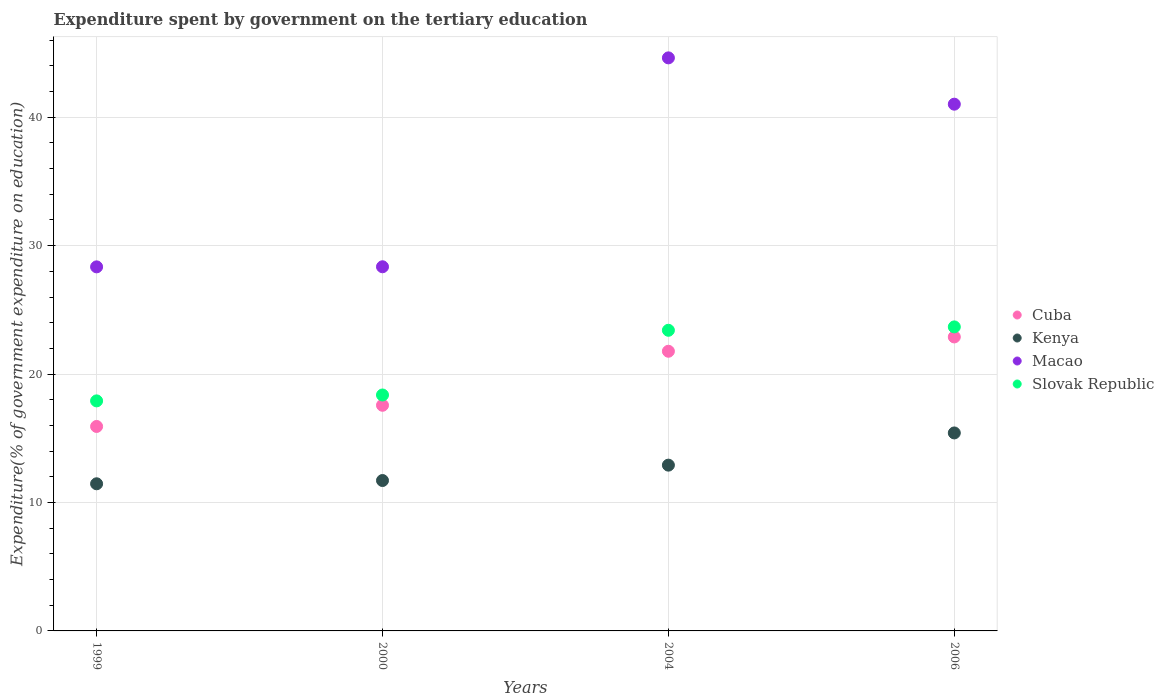How many different coloured dotlines are there?
Ensure brevity in your answer.  4. Is the number of dotlines equal to the number of legend labels?
Offer a terse response. Yes. What is the expenditure spent by government on the tertiary education in Slovak Republic in 1999?
Offer a very short reply. 17.91. Across all years, what is the maximum expenditure spent by government on the tertiary education in Cuba?
Your answer should be compact. 22.89. Across all years, what is the minimum expenditure spent by government on the tertiary education in Cuba?
Keep it short and to the point. 15.92. In which year was the expenditure spent by government on the tertiary education in Kenya minimum?
Make the answer very short. 1999. What is the total expenditure spent by government on the tertiary education in Cuba in the graph?
Provide a succinct answer. 78.17. What is the difference between the expenditure spent by government on the tertiary education in Slovak Republic in 2000 and that in 2006?
Your answer should be compact. -5.3. What is the difference between the expenditure spent by government on the tertiary education in Kenya in 2004 and the expenditure spent by government on the tertiary education in Cuba in 1999?
Offer a very short reply. -3.01. What is the average expenditure spent by government on the tertiary education in Cuba per year?
Your response must be concise. 19.54. In the year 2004, what is the difference between the expenditure spent by government on the tertiary education in Macao and expenditure spent by government on the tertiary education in Slovak Republic?
Provide a succinct answer. 21.21. In how many years, is the expenditure spent by government on the tertiary education in Cuba greater than 16 %?
Your answer should be compact. 3. What is the ratio of the expenditure spent by government on the tertiary education in Slovak Republic in 1999 to that in 2004?
Provide a short and direct response. 0.77. What is the difference between the highest and the second highest expenditure spent by government on the tertiary education in Kenya?
Provide a succinct answer. 2.51. What is the difference between the highest and the lowest expenditure spent by government on the tertiary education in Macao?
Ensure brevity in your answer.  16.27. Is it the case that in every year, the sum of the expenditure spent by government on the tertiary education in Slovak Republic and expenditure spent by government on the tertiary education in Kenya  is greater than the sum of expenditure spent by government on the tertiary education in Macao and expenditure spent by government on the tertiary education in Cuba?
Make the answer very short. No. Is it the case that in every year, the sum of the expenditure spent by government on the tertiary education in Cuba and expenditure spent by government on the tertiary education in Macao  is greater than the expenditure spent by government on the tertiary education in Slovak Republic?
Provide a short and direct response. Yes. Does the expenditure spent by government on the tertiary education in Cuba monotonically increase over the years?
Make the answer very short. Yes. Is the expenditure spent by government on the tertiary education in Cuba strictly greater than the expenditure spent by government on the tertiary education in Kenya over the years?
Offer a very short reply. Yes. Is the expenditure spent by government on the tertiary education in Kenya strictly less than the expenditure spent by government on the tertiary education in Macao over the years?
Your answer should be compact. Yes. How many years are there in the graph?
Give a very brief answer. 4. Where does the legend appear in the graph?
Offer a very short reply. Center right. How many legend labels are there?
Provide a short and direct response. 4. What is the title of the graph?
Keep it short and to the point. Expenditure spent by government on the tertiary education. Does "Bulgaria" appear as one of the legend labels in the graph?
Offer a terse response. No. What is the label or title of the X-axis?
Keep it short and to the point. Years. What is the label or title of the Y-axis?
Keep it short and to the point. Expenditure(% of government expenditure on education). What is the Expenditure(% of government expenditure on education) of Cuba in 1999?
Your answer should be very brief. 15.92. What is the Expenditure(% of government expenditure on education) in Kenya in 1999?
Make the answer very short. 11.46. What is the Expenditure(% of government expenditure on education) in Macao in 1999?
Ensure brevity in your answer.  28.35. What is the Expenditure(% of government expenditure on education) of Slovak Republic in 1999?
Offer a terse response. 17.91. What is the Expenditure(% of government expenditure on education) of Cuba in 2000?
Your answer should be compact. 17.57. What is the Expenditure(% of government expenditure on education) of Kenya in 2000?
Keep it short and to the point. 11.71. What is the Expenditure(% of government expenditure on education) in Macao in 2000?
Your answer should be compact. 28.36. What is the Expenditure(% of government expenditure on education) in Slovak Republic in 2000?
Keep it short and to the point. 18.37. What is the Expenditure(% of government expenditure on education) of Cuba in 2004?
Your response must be concise. 21.78. What is the Expenditure(% of government expenditure on education) of Kenya in 2004?
Your response must be concise. 12.91. What is the Expenditure(% of government expenditure on education) in Macao in 2004?
Provide a short and direct response. 44.63. What is the Expenditure(% of government expenditure on education) of Slovak Republic in 2004?
Offer a very short reply. 23.41. What is the Expenditure(% of government expenditure on education) of Cuba in 2006?
Offer a very short reply. 22.89. What is the Expenditure(% of government expenditure on education) in Kenya in 2006?
Keep it short and to the point. 15.42. What is the Expenditure(% of government expenditure on education) of Macao in 2006?
Make the answer very short. 41.02. What is the Expenditure(% of government expenditure on education) of Slovak Republic in 2006?
Ensure brevity in your answer.  23.68. Across all years, what is the maximum Expenditure(% of government expenditure on education) of Cuba?
Offer a very short reply. 22.89. Across all years, what is the maximum Expenditure(% of government expenditure on education) in Kenya?
Your response must be concise. 15.42. Across all years, what is the maximum Expenditure(% of government expenditure on education) of Macao?
Your response must be concise. 44.63. Across all years, what is the maximum Expenditure(% of government expenditure on education) in Slovak Republic?
Ensure brevity in your answer.  23.68. Across all years, what is the minimum Expenditure(% of government expenditure on education) of Cuba?
Provide a short and direct response. 15.92. Across all years, what is the minimum Expenditure(% of government expenditure on education) in Kenya?
Provide a succinct answer. 11.46. Across all years, what is the minimum Expenditure(% of government expenditure on education) in Macao?
Offer a very short reply. 28.35. Across all years, what is the minimum Expenditure(% of government expenditure on education) in Slovak Republic?
Your answer should be very brief. 17.91. What is the total Expenditure(% of government expenditure on education) in Cuba in the graph?
Provide a succinct answer. 78.17. What is the total Expenditure(% of government expenditure on education) of Kenya in the graph?
Your answer should be compact. 51.5. What is the total Expenditure(% of government expenditure on education) of Macao in the graph?
Keep it short and to the point. 142.35. What is the total Expenditure(% of government expenditure on education) of Slovak Republic in the graph?
Give a very brief answer. 83.37. What is the difference between the Expenditure(% of government expenditure on education) of Cuba in 1999 and that in 2000?
Keep it short and to the point. -1.65. What is the difference between the Expenditure(% of government expenditure on education) of Kenya in 1999 and that in 2000?
Offer a terse response. -0.25. What is the difference between the Expenditure(% of government expenditure on education) of Macao in 1999 and that in 2000?
Give a very brief answer. -0.01. What is the difference between the Expenditure(% of government expenditure on education) of Slovak Republic in 1999 and that in 2000?
Your response must be concise. -0.46. What is the difference between the Expenditure(% of government expenditure on education) of Cuba in 1999 and that in 2004?
Provide a short and direct response. -5.86. What is the difference between the Expenditure(% of government expenditure on education) of Kenya in 1999 and that in 2004?
Make the answer very short. -1.45. What is the difference between the Expenditure(% of government expenditure on education) in Macao in 1999 and that in 2004?
Your answer should be very brief. -16.27. What is the difference between the Expenditure(% of government expenditure on education) in Slovak Republic in 1999 and that in 2004?
Ensure brevity in your answer.  -5.5. What is the difference between the Expenditure(% of government expenditure on education) of Cuba in 1999 and that in 2006?
Provide a succinct answer. -6.97. What is the difference between the Expenditure(% of government expenditure on education) of Kenya in 1999 and that in 2006?
Ensure brevity in your answer.  -3.96. What is the difference between the Expenditure(% of government expenditure on education) in Macao in 1999 and that in 2006?
Provide a short and direct response. -12.67. What is the difference between the Expenditure(% of government expenditure on education) of Slovak Republic in 1999 and that in 2006?
Offer a very short reply. -5.76. What is the difference between the Expenditure(% of government expenditure on education) in Cuba in 2000 and that in 2004?
Provide a short and direct response. -4.21. What is the difference between the Expenditure(% of government expenditure on education) in Kenya in 2000 and that in 2004?
Offer a terse response. -1.2. What is the difference between the Expenditure(% of government expenditure on education) in Macao in 2000 and that in 2004?
Keep it short and to the point. -16.27. What is the difference between the Expenditure(% of government expenditure on education) in Slovak Republic in 2000 and that in 2004?
Make the answer very short. -5.04. What is the difference between the Expenditure(% of government expenditure on education) of Cuba in 2000 and that in 2006?
Make the answer very short. -5.32. What is the difference between the Expenditure(% of government expenditure on education) of Kenya in 2000 and that in 2006?
Ensure brevity in your answer.  -3.71. What is the difference between the Expenditure(% of government expenditure on education) of Macao in 2000 and that in 2006?
Offer a very short reply. -12.66. What is the difference between the Expenditure(% of government expenditure on education) of Slovak Republic in 2000 and that in 2006?
Give a very brief answer. -5.3. What is the difference between the Expenditure(% of government expenditure on education) of Cuba in 2004 and that in 2006?
Make the answer very short. -1.11. What is the difference between the Expenditure(% of government expenditure on education) of Kenya in 2004 and that in 2006?
Offer a very short reply. -2.51. What is the difference between the Expenditure(% of government expenditure on education) of Macao in 2004 and that in 2006?
Give a very brief answer. 3.61. What is the difference between the Expenditure(% of government expenditure on education) of Slovak Republic in 2004 and that in 2006?
Your answer should be compact. -0.26. What is the difference between the Expenditure(% of government expenditure on education) in Cuba in 1999 and the Expenditure(% of government expenditure on education) in Kenya in 2000?
Your answer should be very brief. 4.21. What is the difference between the Expenditure(% of government expenditure on education) of Cuba in 1999 and the Expenditure(% of government expenditure on education) of Macao in 2000?
Ensure brevity in your answer.  -12.44. What is the difference between the Expenditure(% of government expenditure on education) of Cuba in 1999 and the Expenditure(% of government expenditure on education) of Slovak Republic in 2000?
Your answer should be very brief. -2.45. What is the difference between the Expenditure(% of government expenditure on education) in Kenya in 1999 and the Expenditure(% of government expenditure on education) in Macao in 2000?
Keep it short and to the point. -16.9. What is the difference between the Expenditure(% of government expenditure on education) of Kenya in 1999 and the Expenditure(% of government expenditure on education) of Slovak Republic in 2000?
Offer a very short reply. -6.91. What is the difference between the Expenditure(% of government expenditure on education) of Macao in 1999 and the Expenditure(% of government expenditure on education) of Slovak Republic in 2000?
Your answer should be compact. 9.98. What is the difference between the Expenditure(% of government expenditure on education) in Cuba in 1999 and the Expenditure(% of government expenditure on education) in Kenya in 2004?
Provide a short and direct response. 3.01. What is the difference between the Expenditure(% of government expenditure on education) in Cuba in 1999 and the Expenditure(% of government expenditure on education) in Macao in 2004?
Provide a short and direct response. -28.7. What is the difference between the Expenditure(% of government expenditure on education) of Cuba in 1999 and the Expenditure(% of government expenditure on education) of Slovak Republic in 2004?
Offer a very short reply. -7.49. What is the difference between the Expenditure(% of government expenditure on education) of Kenya in 1999 and the Expenditure(% of government expenditure on education) of Macao in 2004?
Ensure brevity in your answer.  -33.17. What is the difference between the Expenditure(% of government expenditure on education) in Kenya in 1999 and the Expenditure(% of government expenditure on education) in Slovak Republic in 2004?
Ensure brevity in your answer.  -11.95. What is the difference between the Expenditure(% of government expenditure on education) of Macao in 1999 and the Expenditure(% of government expenditure on education) of Slovak Republic in 2004?
Provide a short and direct response. 4.94. What is the difference between the Expenditure(% of government expenditure on education) in Cuba in 1999 and the Expenditure(% of government expenditure on education) in Kenya in 2006?
Provide a succinct answer. 0.51. What is the difference between the Expenditure(% of government expenditure on education) in Cuba in 1999 and the Expenditure(% of government expenditure on education) in Macao in 2006?
Offer a terse response. -25.1. What is the difference between the Expenditure(% of government expenditure on education) of Cuba in 1999 and the Expenditure(% of government expenditure on education) of Slovak Republic in 2006?
Your response must be concise. -7.75. What is the difference between the Expenditure(% of government expenditure on education) in Kenya in 1999 and the Expenditure(% of government expenditure on education) in Macao in 2006?
Ensure brevity in your answer.  -29.56. What is the difference between the Expenditure(% of government expenditure on education) of Kenya in 1999 and the Expenditure(% of government expenditure on education) of Slovak Republic in 2006?
Ensure brevity in your answer.  -12.22. What is the difference between the Expenditure(% of government expenditure on education) of Macao in 1999 and the Expenditure(% of government expenditure on education) of Slovak Republic in 2006?
Your answer should be very brief. 4.67. What is the difference between the Expenditure(% of government expenditure on education) of Cuba in 2000 and the Expenditure(% of government expenditure on education) of Kenya in 2004?
Make the answer very short. 4.66. What is the difference between the Expenditure(% of government expenditure on education) in Cuba in 2000 and the Expenditure(% of government expenditure on education) in Macao in 2004?
Your response must be concise. -27.05. What is the difference between the Expenditure(% of government expenditure on education) of Cuba in 2000 and the Expenditure(% of government expenditure on education) of Slovak Republic in 2004?
Make the answer very short. -5.84. What is the difference between the Expenditure(% of government expenditure on education) of Kenya in 2000 and the Expenditure(% of government expenditure on education) of Macao in 2004?
Make the answer very short. -32.91. What is the difference between the Expenditure(% of government expenditure on education) in Kenya in 2000 and the Expenditure(% of government expenditure on education) in Slovak Republic in 2004?
Your answer should be very brief. -11.7. What is the difference between the Expenditure(% of government expenditure on education) of Macao in 2000 and the Expenditure(% of government expenditure on education) of Slovak Republic in 2004?
Your response must be concise. 4.95. What is the difference between the Expenditure(% of government expenditure on education) of Cuba in 2000 and the Expenditure(% of government expenditure on education) of Kenya in 2006?
Your answer should be compact. 2.15. What is the difference between the Expenditure(% of government expenditure on education) in Cuba in 2000 and the Expenditure(% of government expenditure on education) in Macao in 2006?
Provide a short and direct response. -23.45. What is the difference between the Expenditure(% of government expenditure on education) of Cuba in 2000 and the Expenditure(% of government expenditure on education) of Slovak Republic in 2006?
Your answer should be very brief. -6.1. What is the difference between the Expenditure(% of government expenditure on education) in Kenya in 2000 and the Expenditure(% of government expenditure on education) in Macao in 2006?
Provide a short and direct response. -29.31. What is the difference between the Expenditure(% of government expenditure on education) of Kenya in 2000 and the Expenditure(% of government expenditure on education) of Slovak Republic in 2006?
Provide a short and direct response. -11.96. What is the difference between the Expenditure(% of government expenditure on education) in Macao in 2000 and the Expenditure(% of government expenditure on education) in Slovak Republic in 2006?
Your answer should be compact. 4.68. What is the difference between the Expenditure(% of government expenditure on education) of Cuba in 2004 and the Expenditure(% of government expenditure on education) of Kenya in 2006?
Your answer should be compact. 6.36. What is the difference between the Expenditure(% of government expenditure on education) in Cuba in 2004 and the Expenditure(% of government expenditure on education) in Macao in 2006?
Give a very brief answer. -19.24. What is the difference between the Expenditure(% of government expenditure on education) of Cuba in 2004 and the Expenditure(% of government expenditure on education) of Slovak Republic in 2006?
Offer a very short reply. -1.9. What is the difference between the Expenditure(% of government expenditure on education) of Kenya in 2004 and the Expenditure(% of government expenditure on education) of Macao in 2006?
Your answer should be compact. -28.11. What is the difference between the Expenditure(% of government expenditure on education) of Kenya in 2004 and the Expenditure(% of government expenditure on education) of Slovak Republic in 2006?
Your answer should be very brief. -10.77. What is the difference between the Expenditure(% of government expenditure on education) of Macao in 2004 and the Expenditure(% of government expenditure on education) of Slovak Republic in 2006?
Make the answer very short. 20.95. What is the average Expenditure(% of government expenditure on education) of Cuba per year?
Offer a terse response. 19.54. What is the average Expenditure(% of government expenditure on education) in Kenya per year?
Make the answer very short. 12.87. What is the average Expenditure(% of government expenditure on education) of Macao per year?
Give a very brief answer. 35.59. What is the average Expenditure(% of government expenditure on education) in Slovak Republic per year?
Ensure brevity in your answer.  20.84. In the year 1999, what is the difference between the Expenditure(% of government expenditure on education) of Cuba and Expenditure(% of government expenditure on education) of Kenya?
Keep it short and to the point. 4.46. In the year 1999, what is the difference between the Expenditure(% of government expenditure on education) in Cuba and Expenditure(% of government expenditure on education) in Macao?
Ensure brevity in your answer.  -12.43. In the year 1999, what is the difference between the Expenditure(% of government expenditure on education) of Cuba and Expenditure(% of government expenditure on education) of Slovak Republic?
Give a very brief answer. -1.99. In the year 1999, what is the difference between the Expenditure(% of government expenditure on education) in Kenya and Expenditure(% of government expenditure on education) in Macao?
Your response must be concise. -16.89. In the year 1999, what is the difference between the Expenditure(% of government expenditure on education) of Kenya and Expenditure(% of government expenditure on education) of Slovak Republic?
Ensure brevity in your answer.  -6.46. In the year 1999, what is the difference between the Expenditure(% of government expenditure on education) of Macao and Expenditure(% of government expenditure on education) of Slovak Republic?
Provide a succinct answer. 10.44. In the year 2000, what is the difference between the Expenditure(% of government expenditure on education) in Cuba and Expenditure(% of government expenditure on education) in Kenya?
Provide a short and direct response. 5.86. In the year 2000, what is the difference between the Expenditure(% of government expenditure on education) in Cuba and Expenditure(% of government expenditure on education) in Macao?
Your response must be concise. -10.79. In the year 2000, what is the difference between the Expenditure(% of government expenditure on education) in Cuba and Expenditure(% of government expenditure on education) in Slovak Republic?
Your response must be concise. -0.8. In the year 2000, what is the difference between the Expenditure(% of government expenditure on education) of Kenya and Expenditure(% of government expenditure on education) of Macao?
Offer a terse response. -16.65. In the year 2000, what is the difference between the Expenditure(% of government expenditure on education) in Kenya and Expenditure(% of government expenditure on education) in Slovak Republic?
Ensure brevity in your answer.  -6.66. In the year 2000, what is the difference between the Expenditure(% of government expenditure on education) of Macao and Expenditure(% of government expenditure on education) of Slovak Republic?
Offer a terse response. 9.98. In the year 2004, what is the difference between the Expenditure(% of government expenditure on education) in Cuba and Expenditure(% of government expenditure on education) in Kenya?
Keep it short and to the point. 8.87. In the year 2004, what is the difference between the Expenditure(% of government expenditure on education) in Cuba and Expenditure(% of government expenditure on education) in Macao?
Offer a terse response. -22.85. In the year 2004, what is the difference between the Expenditure(% of government expenditure on education) of Cuba and Expenditure(% of government expenditure on education) of Slovak Republic?
Offer a terse response. -1.63. In the year 2004, what is the difference between the Expenditure(% of government expenditure on education) of Kenya and Expenditure(% of government expenditure on education) of Macao?
Provide a short and direct response. -31.72. In the year 2004, what is the difference between the Expenditure(% of government expenditure on education) in Kenya and Expenditure(% of government expenditure on education) in Slovak Republic?
Your response must be concise. -10.5. In the year 2004, what is the difference between the Expenditure(% of government expenditure on education) in Macao and Expenditure(% of government expenditure on education) in Slovak Republic?
Your answer should be very brief. 21.21. In the year 2006, what is the difference between the Expenditure(% of government expenditure on education) in Cuba and Expenditure(% of government expenditure on education) in Kenya?
Your answer should be very brief. 7.48. In the year 2006, what is the difference between the Expenditure(% of government expenditure on education) in Cuba and Expenditure(% of government expenditure on education) in Macao?
Give a very brief answer. -18.13. In the year 2006, what is the difference between the Expenditure(% of government expenditure on education) of Cuba and Expenditure(% of government expenditure on education) of Slovak Republic?
Your answer should be compact. -0.78. In the year 2006, what is the difference between the Expenditure(% of government expenditure on education) of Kenya and Expenditure(% of government expenditure on education) of Macao?
Keep it short and to the point. -25.6. In the year 2006, what is the difference between the Expenditure(% of government expenditure on education) of Kenya and Expenditure(% of government expenditure on education) of Slovak Republic?
Ensure brevity in your answer.  -8.26. In the year 2006, what is the difference between the Expenditure(% of government expenditure on education) of Macao and Expenditure(% of government expenditure on education) of Slovak Republic?
Offer a terse response. 17.34. What is the ratio of the Expenditure(% of government expenditure on education) in Cuba in 1999 to that in 2000?
Offer a very short reply. 0.91. What is the ratio of the Expenditure(% of government expenditure on education) in Kenya in 1999 to that in 2000?
Ensure brevity in your answer.  0.98. What is the ratio of the Expenditure(% of government expenditure on education) in Macao in 1999 to that in 2000?
Your answer should be compact. 1. What is the ratio of the Expenditure(% of government expenditure on education) of Slovak Republic in 1999 to that in 2000?
Provide a succinct answer. 0.97. What is the ratio of the Expenditure(% of government expenditure on education) in Cuba in 1999 to that in 2004?
Offer a very short reply. 0.73. What is the ratio of the Expenditure(% of government expenditure on education) of Kenya in 1999 to that in 2004?
Provide a succinct answer. 0.89. What is the ratio of the Expenditure(% of government expenditure on education) in Macao in 1999 to that in 2004?
Your response must be concise. 0.64. What is the ratio of the Expenditure(% of government expenditure on education) of Slovak Republic in 1999 to that in 2004?
Provide a succinct answer. 0.77. What is the ratio of the Expenditure(% of government expenditure on education) in Cuba in 1999 to that in 2006?
Your response must be concise. 0.7. What is the ratio of the Expenditure(% of government expenditure on education) in Kenya in 1999 to that in 2006?
Provide a succinct answer. 0.74. What is the ratio of the Expenditure(% of government expenditure on education) in Macao in 1999 to that in 2006?
Your answer should be very brief. 0.69. What is the ratio of the Expenditure(% of government expenditure on education) in Slovak Republic in 1999 to that in 2006?
Make the answer very short. 0.76. What is the ratio of the Expenditure(% of government expenditure on education) of Cuba in 2000 to that in 2004?
Your answer should be compact. 0.81. What is the ratio of the Expenditure(% of government expenditure on education) in Kenya in 2000 to that in 2004?
Keep it short and to the point. 0.91. What is the ratio of the Expenditure(% of government expenditure on education) of Macao in 2000 to that in 2004?
Your answer should be compact. 0.64. What is the ratio of the Expenditure(% of government expenditure on education) in Slovak Republic in 2000 to that in 2004?
Make the answer very short. 0.78. What is the ratio of the Expenditure(% of government expenditure on education) in Cuba in 2000 to that in 2006?
Offer a very short reply. 0.77. What is the ratio of the Expenditure(% of government expenditure on education) of Kenya in 2000 to that in 2006?
Offer a terse response. 0.76. What is the ratio of the Expenditure(% of government expenditure on education) of Macao in 2000 to that in 2006?
Offer a terse response. 0.69. What is the ratio of the Expenditure(% of government expenditure on education) in Slovak Republic in 2000 to that in 2006?
Your response must be concise. 0.78. What is the ratio of the Expenditure(% of government expenditure on education) in Cuba in 2004 to that in 2006?
Make the answer very short. 0.95. What is the ratio of the Expenditure(% of government expenditure on education) in Kenya in 2004 to that in 2006?
Ensure brevity in your answer.  0.84. What is the ratio of the Expenditure(% of government expenditure on education) in Macao in 2004 to that in 2006?
Provide a succinct answer. 1.09. What is the ratio of the Expenditure(% of government expenditure on education) of Slovak Republic in 2004 to that in 2006?
Provide a succinct answer. 0.99. What is the difference between the highest and the second highest Expenditure(% of government expenditure on education) of Cuba?
Your response must be concise. 1.11. What is the difference between the highest and the second highest Expenditure(% of government expenditure on education) in Kenya?
Provide a succinct answer. 2.51. What is the difference between the highest and the second highest Expenditure(% of government expenditure on education) of Macao?
Provide a short and direct response. 3.61. What is the difference between the highest and the second highest Expenditure(% of government expenditure on education) of Slovak Republic?
Your answer should be compact. 0.26. What is the difference between the highest and the lowest Expenditure(% of government expenditure on education) in Cuba?
Provide a succinct answer. 6.97. What is the difference between the highest and the lowest Expenditure(% of government expenditure on education) of Kenya?
Your answer should be compact. 3.96. What is the difference between the highest and the lowest Expenditure(% of government expenditure on education) in Macao?
Ensure brevity in your answer.  16.27. What is the difference between the highest and the lowest Expenditure(% of government expenditure on education) of Slovak Republic?
Ensure brevity in your answer.  5.76. 